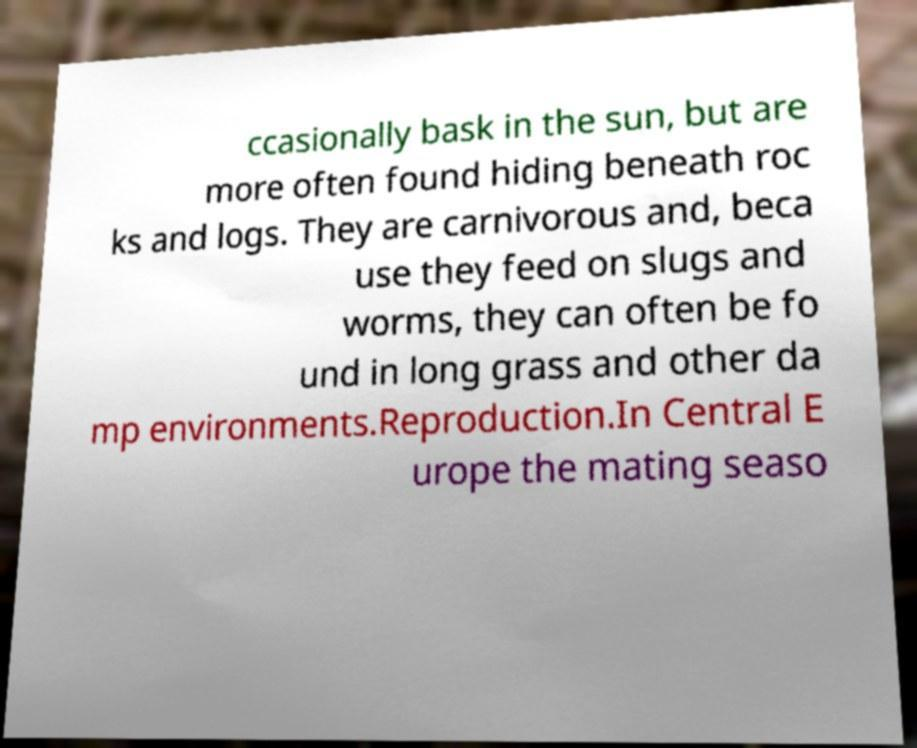Could you assist in decoding the text presented in this image and type it out clearly? ccasionally bask in the sun, but are more often found hiding beneath roc ks and logs. They are carnivorous and, beca use they feed on slugs and worms, they can often be fo und in long grass and other da mp environments.Reproduction.In Central E urope the mating seaso 